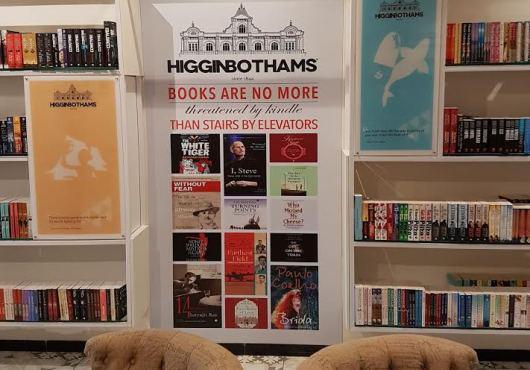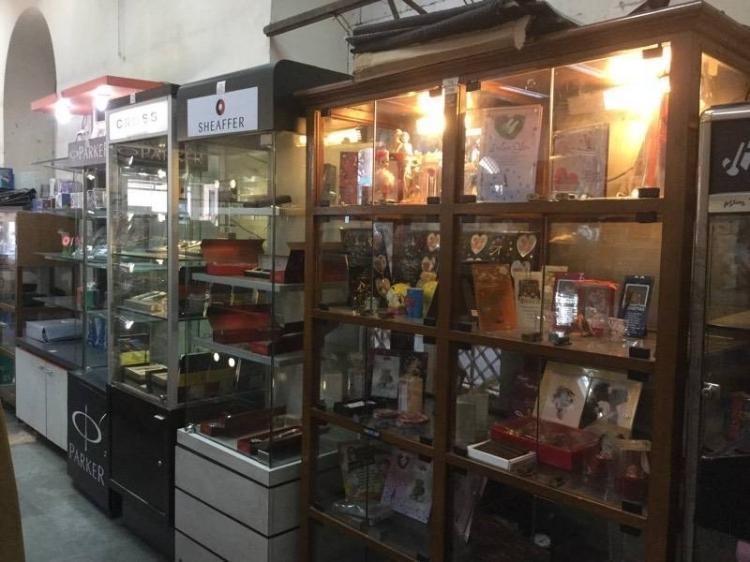The first image is the image on the left, the second image is the image on the right. Considering the images on both sides, is "Although the image to the left is a bookstore, there are no actual books visible." valid? Answer yes or no. No. 